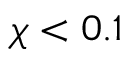Convert formula to latex. <formula><loc_0><loc_0><loc_500><loc_500>\chi < 0 . 1</formula> 